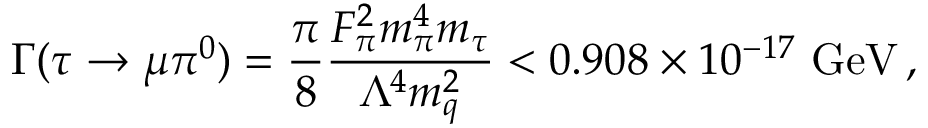Convert formula to latex. <formula><loc_0><loc_0><loc_500><loc_500>\Gamma ( \tau \rightarrow \mu \pi ^ { 0 } ) = \frac { \pi } { 8 } \frac { F _ { \pi } ^ { 2 } m _ { \pi } ^ { 4 } m _ { \tau } } { \Lambda ^ { 4 } m _ { q } ^ { 2 } } < 0 . 9 0 8 \times 1 0 ^ { - 1 7 } G e V \, ,</formula> 